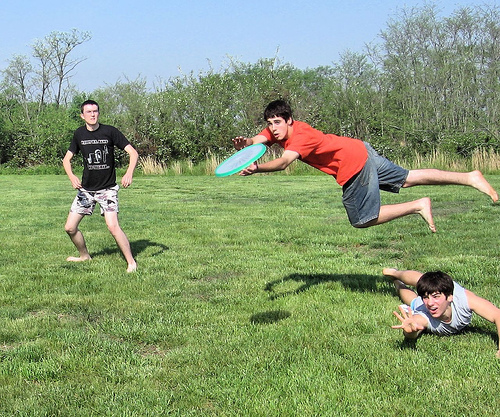Imagine these boys are superheroes training in disguise. What powers might they have? In their superhero personas, the boy jumping to catch the frisbee could have the power of super agility and flight, able to leap great distances and heights. The boy diving on the ground could possess super speed and reflexes, able to dodge and move faster than the eye can see. The boy standing could have the ability to manipulate objects with his mind, catching and throwing the frisbee telekinetically. They are training in disguise, perfecting their abilities unnoticed by the public. 